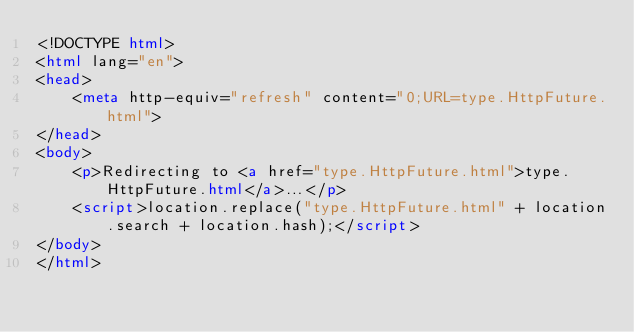<code> <loc_0><loc_0><loc_500><loc_500><_HTML_><!DOCTYPE html>
<html lang="en">
<head>
    <meta http-equiv="refresh" content="0;URL=type.HttpFuture.html">
</head>
<body>
    <p>Redirecting to <a href="type.HttpFuture.html">type.HttpFuture.html</a>...</p>
    <script>location.replace("type.HttpFuture.html" + location.search + location.hash);</script>
</body>
</html></code> 